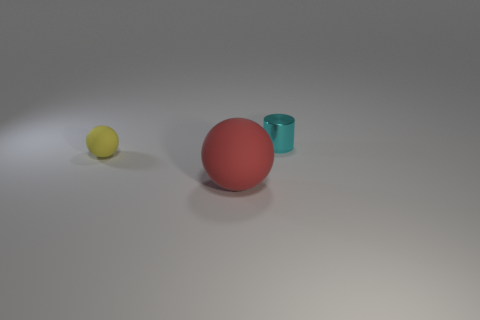There is another rubber thing that is the same shape as the yellow thing; what is its size? Referencing the objects in the image with the same shape as the yellow sphere, the turquoise rubber cylinder appears to be larger in comparison. Specifically, the cylinder's height seems to be approximately three times the diameter of the yellow sphere, and its diameter about the same as the sphere. 